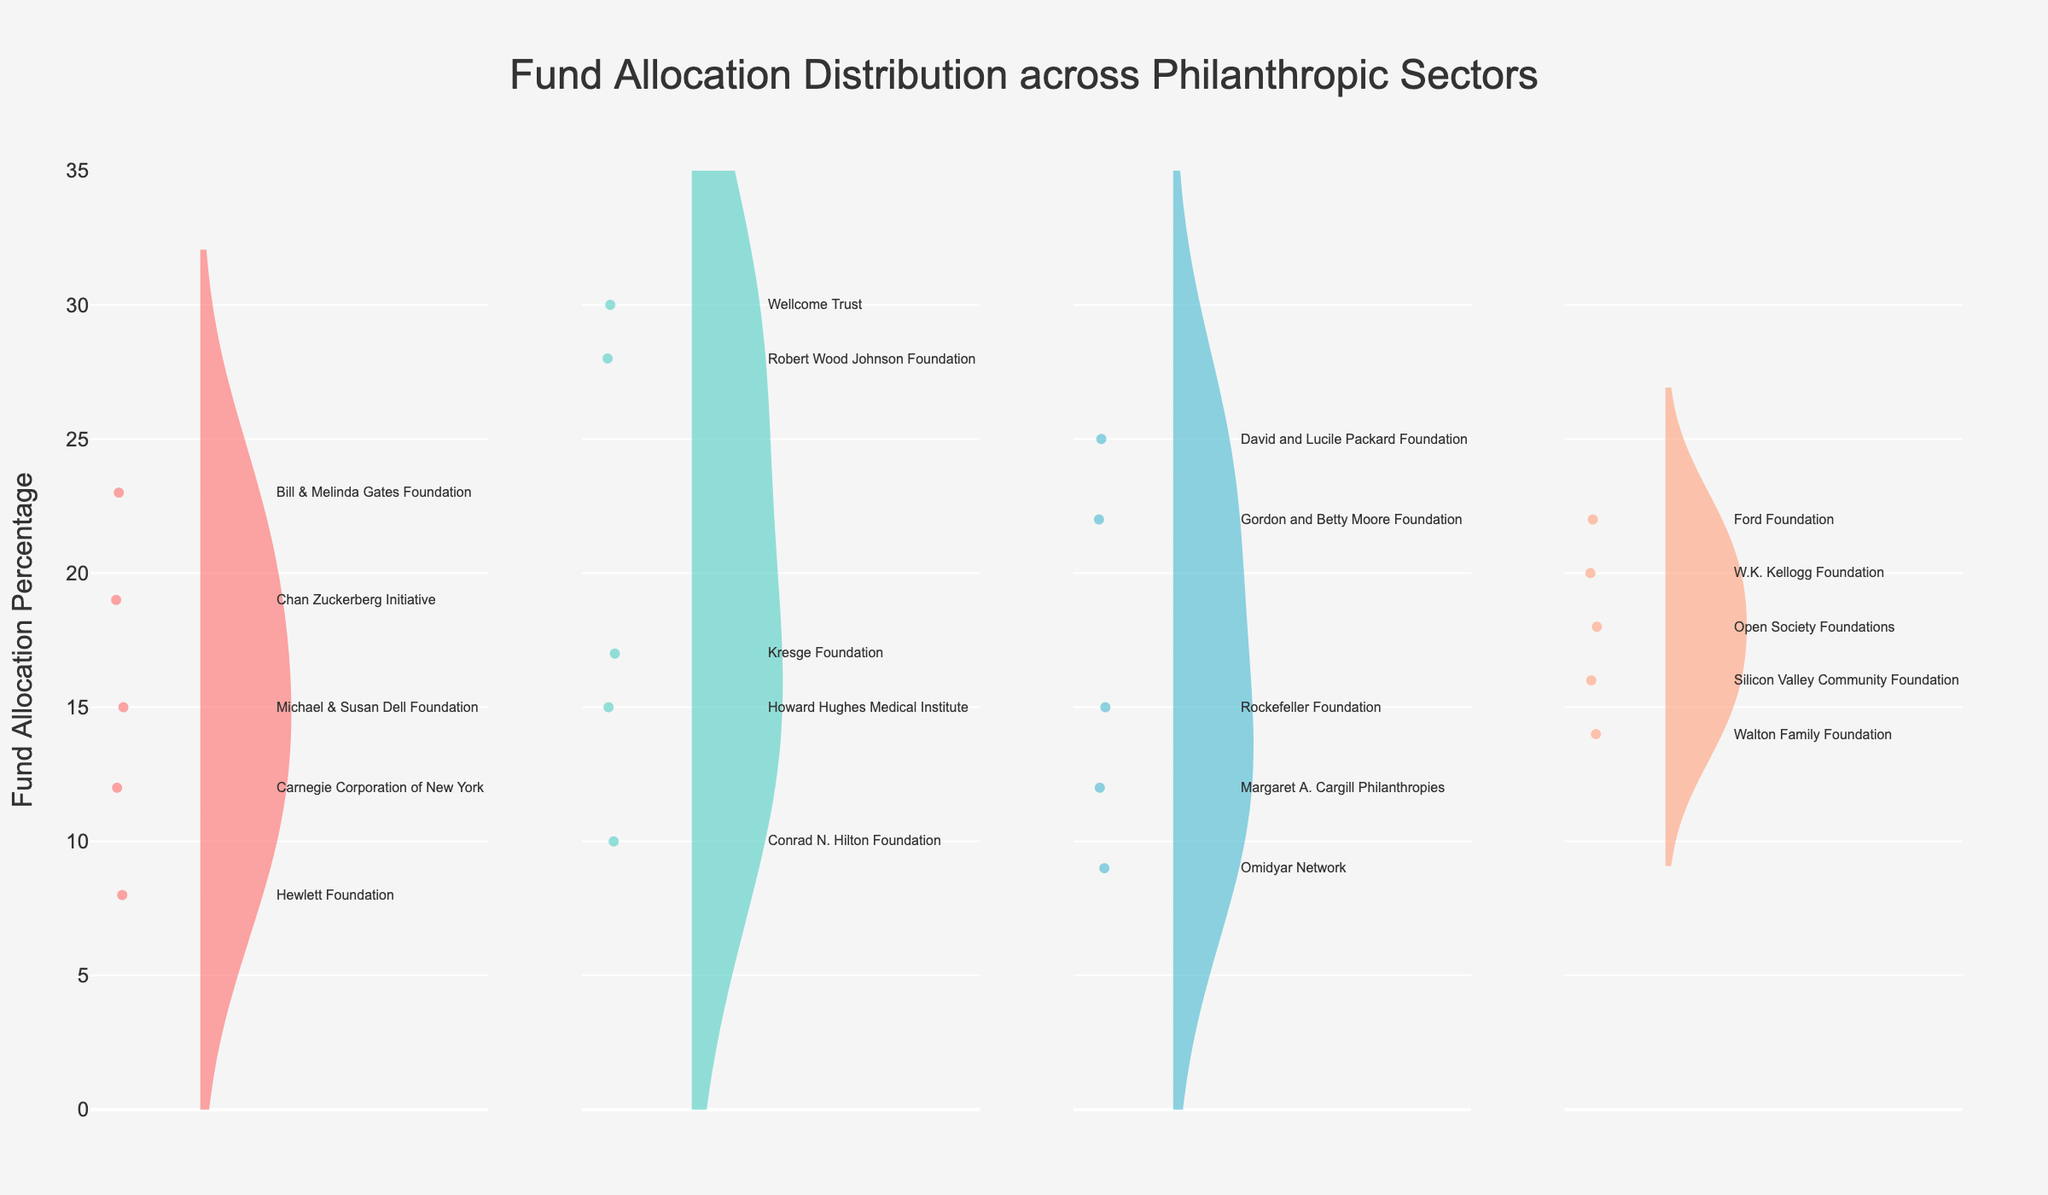What is the title of the figure? The title of the figure is located at the top center and reads "Fund Allocation Distribution across Philanthropic Sectors".
Answer: Fund Allocation Distribution across Philanthropic Sectors Which sector has the highest single fund allocation percentage? By looking at the peaks of the violins, we see that the Health sector has the highest single fund allocation percentage at 30%.
Answer: Health How many sectors are represented in the figure? There are four distinct violins in the figure corresponding to the sectors: Education, Health, Environment, and Poverty Alleviation.
Answer: 4 What is the general range of fund allocation percentages for the Education sector? The violin plot for the Education sector extends roughly between 8% and 23%.
Answer: 8% to 23% Which organization allocated the lowest percentage of funds in the Environment sector? By inspecting the annotations inside the Environment sector's violin, Omidyar Network allocated the lowest percentage at 9%.
Answer: Omidyar Network What is the median fund allocation percentage for the Health sector? The median value is represented by the thick horizontal line within the box of the violin plot for the Health sector, which is approximately at 17%.
Answer: 17% What is the average (mean) fund allocation percentage in the Poverty Alleviation sector? Calculate the mean of the values 22, 18, 14, 16, and 20, which sums up to 90. Divide by 5 to get an average of 18.
Answer: 18% Which sector has the most organizations above 20% in fund allocation? By examining the data points in each violin plot, the Health sector has the most organizations (2) with fund allocations above 20%.
Answer: Health Compare the fund allocation of the Rockefeller Foundation and the Conrad N. Hilton Foundation. Which one allocated more funds? By checking the positions within their respective violins, the Rockefeller Foundation allocated 15% while the Conrad N. Hilton Foundation allocated 10%. Thus, the Rockefeller Foundation allocated more.
Answer: Rockefeller Foundation How do the fund allocations for the Chan Zuckerberg Initiative and the Howard Hughes Medical Institute differ? The Chan Zuckerberg Initiative (Education) allocated 19%, whereas the Howard Hughes Medical Institute (Health) allocated 15%. The Chan Zuckerberg Initiative allocated 4% more.
Answer: 4% more 